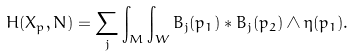Convert formula to latex. <formula><loc_0><loc_0><loc_500><loc_500>H ( { X } _ { p } , N ) = \sum _ { j } \int _ { M } \int _ { W } B _ { j } ( p _ { 1 } ) \ast B _ { j } ( p _ { 2 } ) \wedge \eta ( p _ { 1 } ) .</formula> 